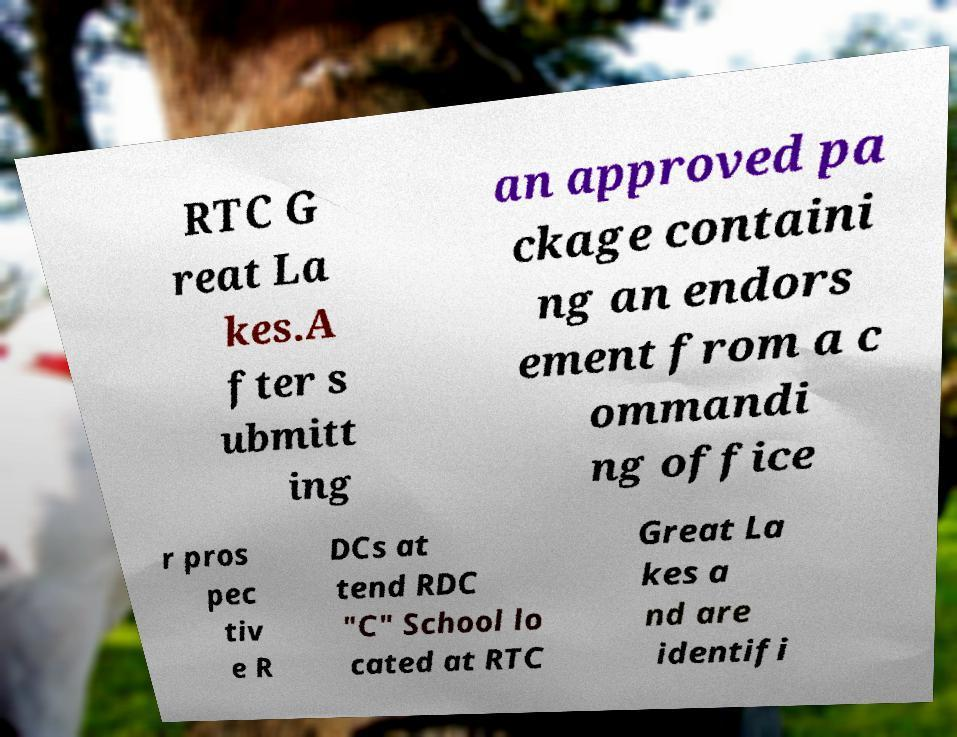Can you accurately transcribe the text from the provided image for me? RTC G reat La kes.A fter s ubmitt ing an approved pa ckage containi ng an endors ement from a c ommandi ng office r pros pec tiv e R DCs at tend RDC "C" School lo cated at RTC Great La kes a nd are identifi 